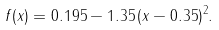Convert formula to latex. <formula><loc_0><loc_0><loc_500><loc_500>f ( x ) = 0 . 1 9 5 - 1 . 3 5 \, ( x - 0 . 3 5 ) ^ { 2 } .</formula> 